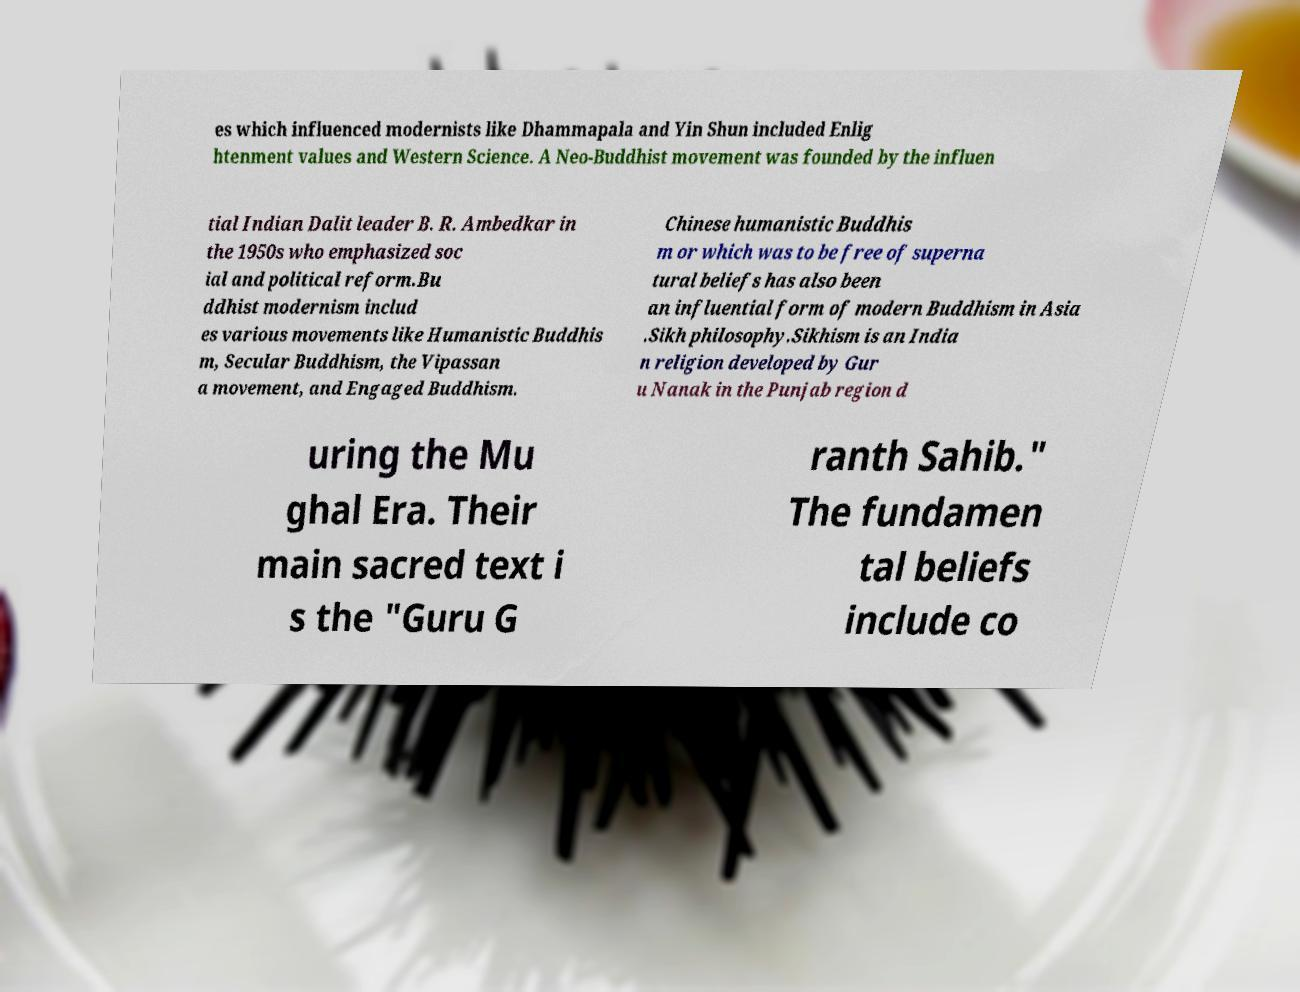I need the written content from this picture converted into text. Can you do that? es which influenced modernists like Dhammapala and Yin Shun included Enlig htenment values and Western Science. A Neo-Buddhist movement was founded by the influen tial Indian Dalit leader B. R. Ambedkar in the 1950s who emphasized soc ial and political reform.Bu ddhist modernism includ es various movements like Humanistic Buddhis m, Secular Buddhism, the Vipassan a movement, and Engaged Buddhism. Chinese humanistic Buddhis m or which was to be free of superna tural beliefs has also been an influential form of modern Buddhism in Asia .Sikh philosophy.Sikhism is an India n religion developed by Gur u Nanak in the Punjab region d uring the Mu ghal Era. Their main sacred text i s the "Guru G ranth Sahib." The fundamen tal beliefs include co 